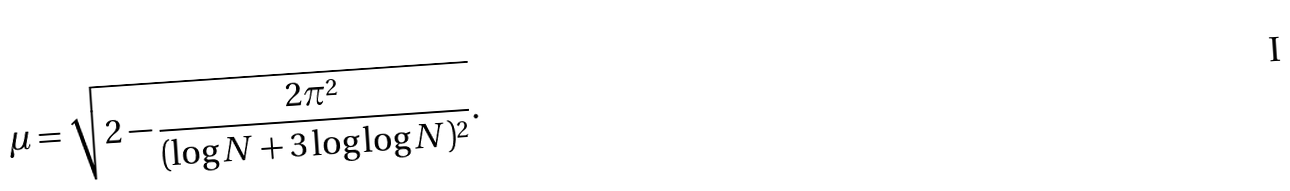Convert formula to latex. <formula><loc_0><loc_0><loc_500><loc_500>\mu = \sqrt { 2 - \frac { 2 \pi ^ { 2 } } { ( \log N + 3 \log \log N ) ^ { 2 } } } .</formula> 